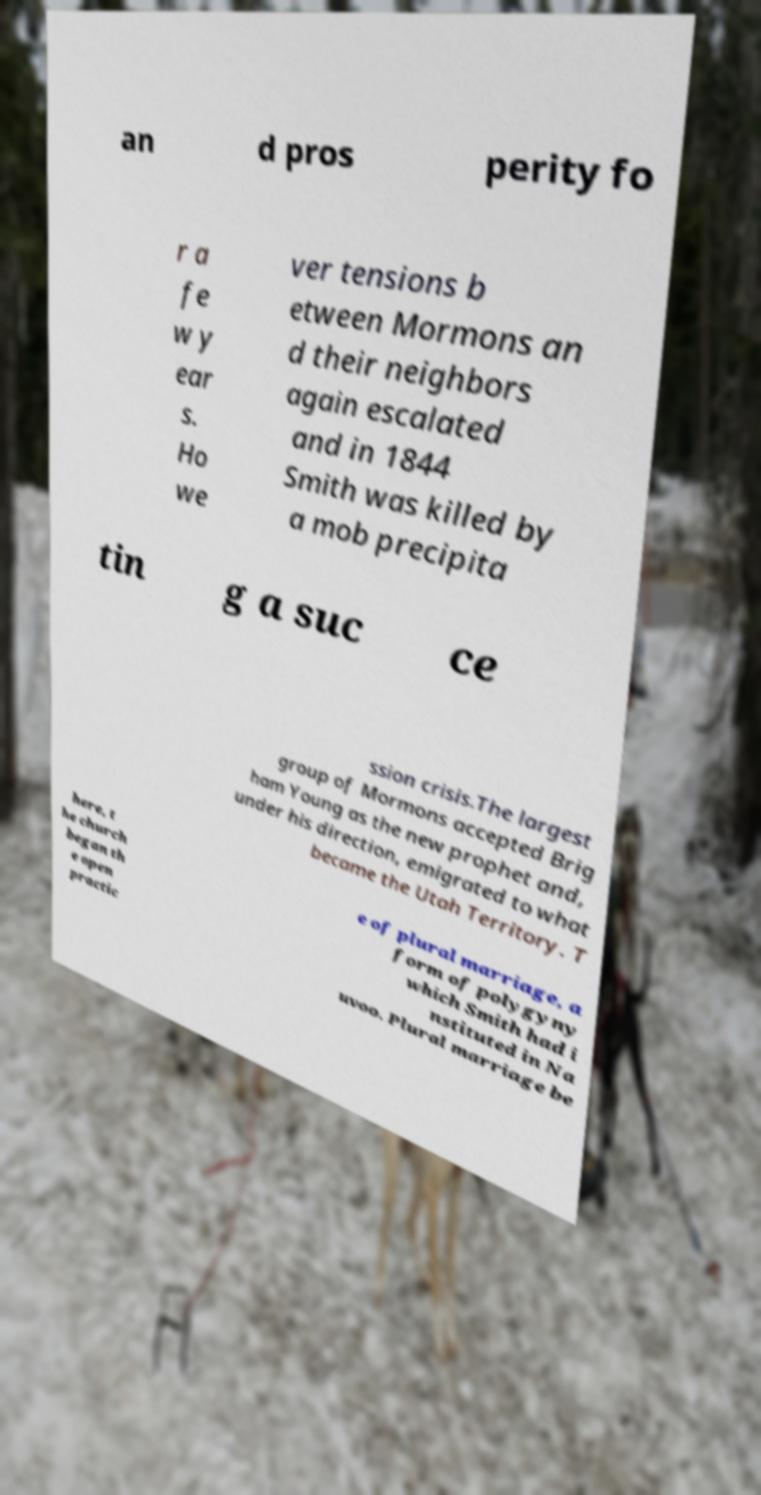Please read and relay the text visible in this image. What does it say? an d pros perity fo r a fe w y ear s. Ho we ver tensions b etween Mormons an d their neighbors again escalated and in 1844 Smith was killed by a mob precipita tin g a suc ce ssion crisis.The largest group of Mormons accepted Brig ham Young as the new prophet and, under his direction, emigrated to what became the Utah Territory. T here, t he church began th e open practic e of plural marriage, a form of polygyny which Smith had i nstituted in Na uvoo. Plural marriage be 